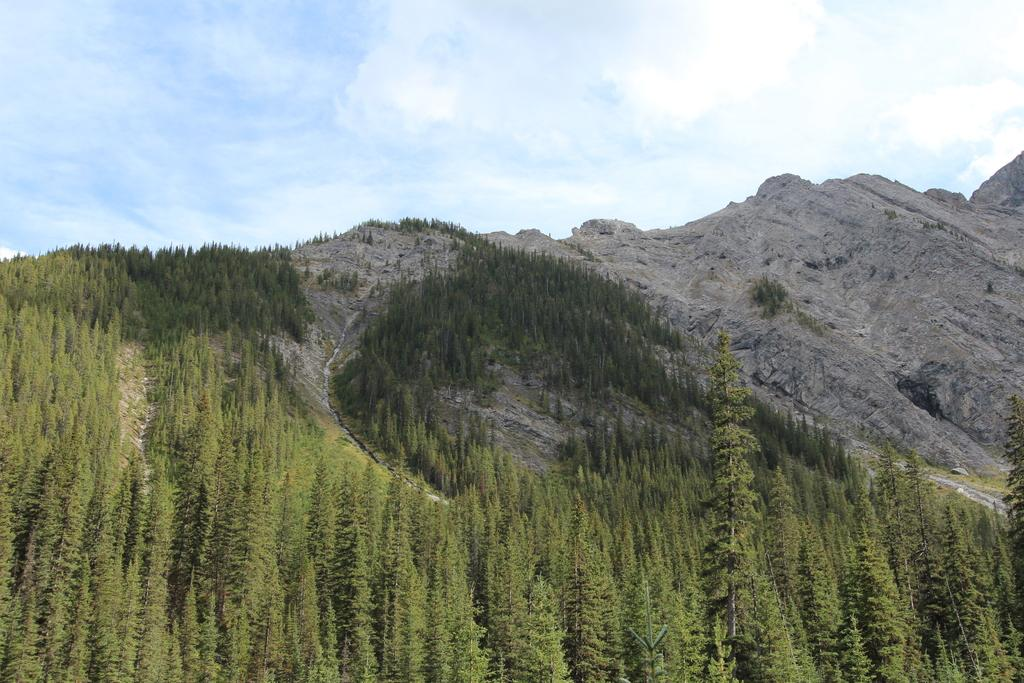What geographical features are located in the center of the image? There are hills in the center of the image. What type of vegetation can be seen at the bottom of the image? There are trees at the bottom of the image. What is visible in the background of the image? The sky is visible in the background of the image. What type of cracker is being used to decorate the trees in the image? There is no cracker present in the image, and the trees are not being decorated. 